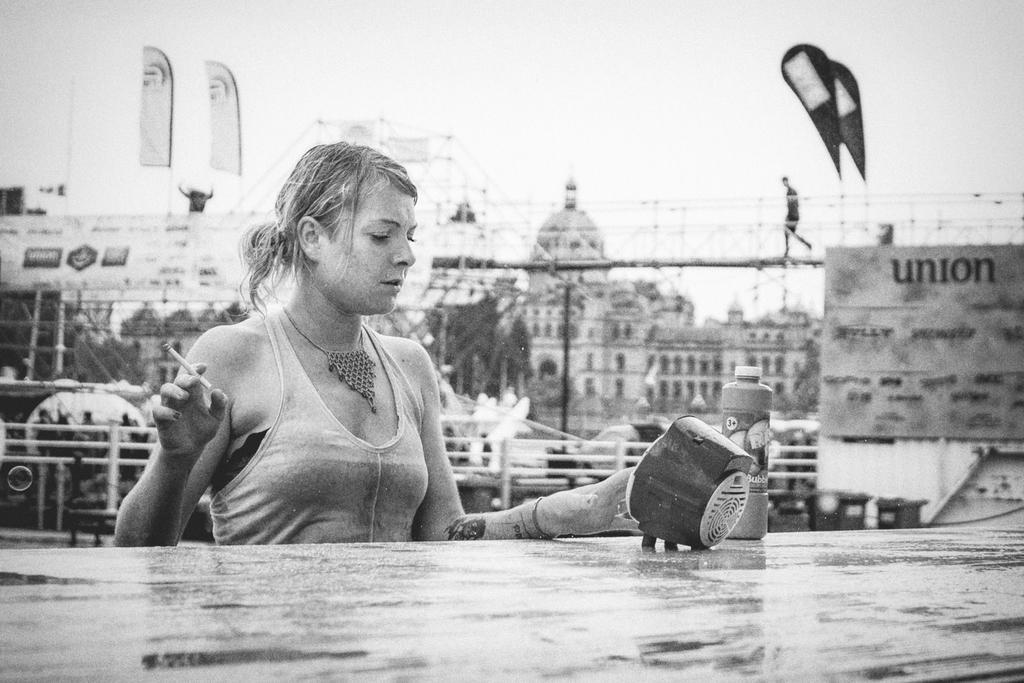How would you summarize this image in a sentence or two? In this picture we can see some buildings and there is a fence, we can see one lady in front of the table and she is holding cigarette along with the box placed on the table. 